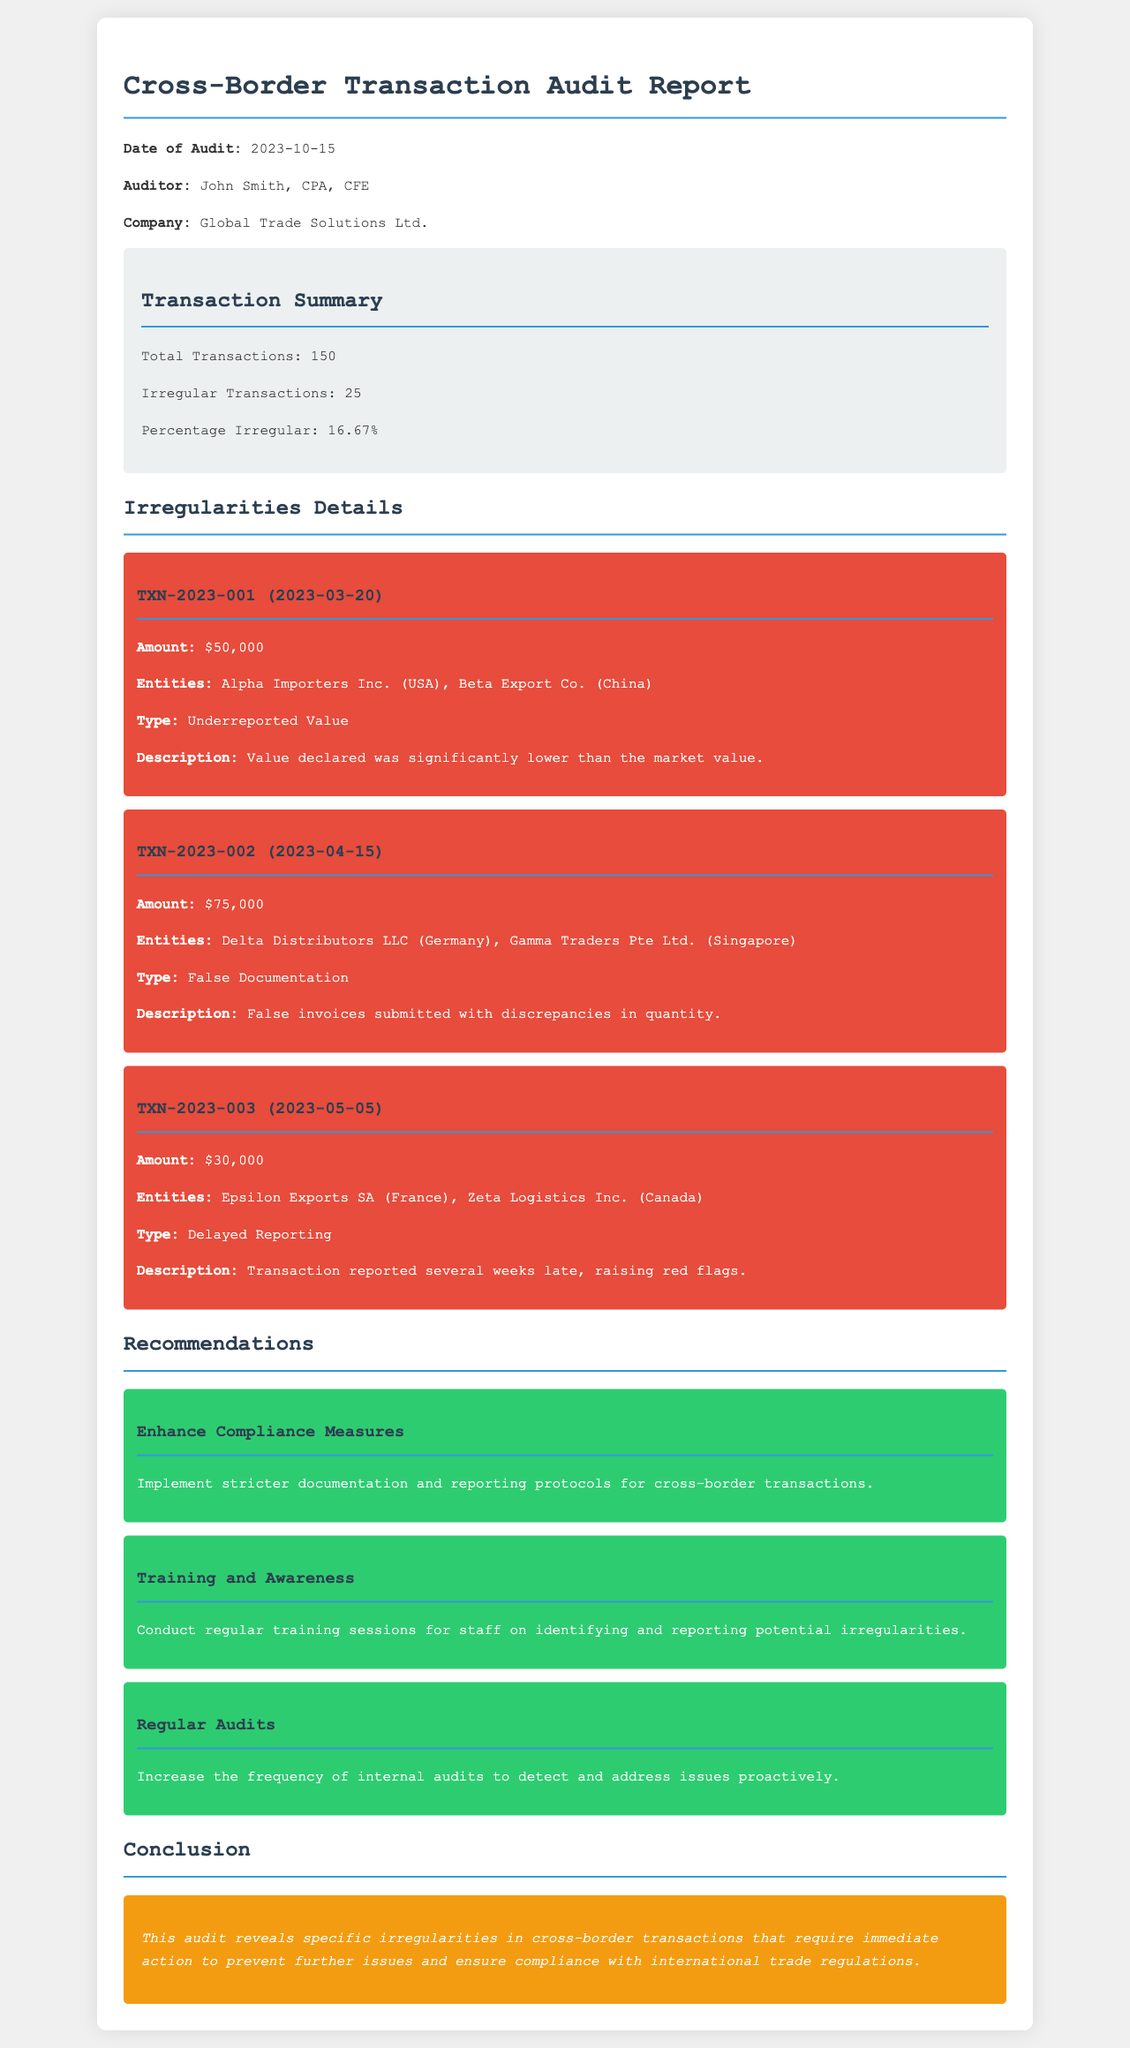What is the date of the audit? The date of the audit is specified in the document, indicating when the audit took place.
Answer: 2023-10-15 Who is the auditor? The audit report includes the name of the individual who conducted the audit.
Answer: John Smith, CPA, CFE How many total transactions were audited? The document provides a summary of the transactions including the total number audited.
Answer: 150 What is the percentage of irregular transactions? The report highlights the percentage of transactions that were found to be irregular.
Answer: 16.67% Which transaction type was associated with TXN-2023-001? The detailed section of irregularities lists the type of irregularity related to the specific transaction.
Answer: Underreported Value What was the amount involved in TXN-2023-002? The document outlines the financial amounts associated with each irregular transaction.
Answer: $75,000 What recommendation is given to enhance compliance? The recommendations section of the document mentions measures to improve compliance protocols.
Answer: Implement stricter documentation and reporting protocols for cross-border transactions What is the main conclusion of the audit? The conclusion summarizes the overall findings and proposed actions based on the audit's outcomes.
Answer: This audit reveals specific irregularities in cross-border transactions that require immediate action to prevent further issues and ensure compliance with international trade regulations 